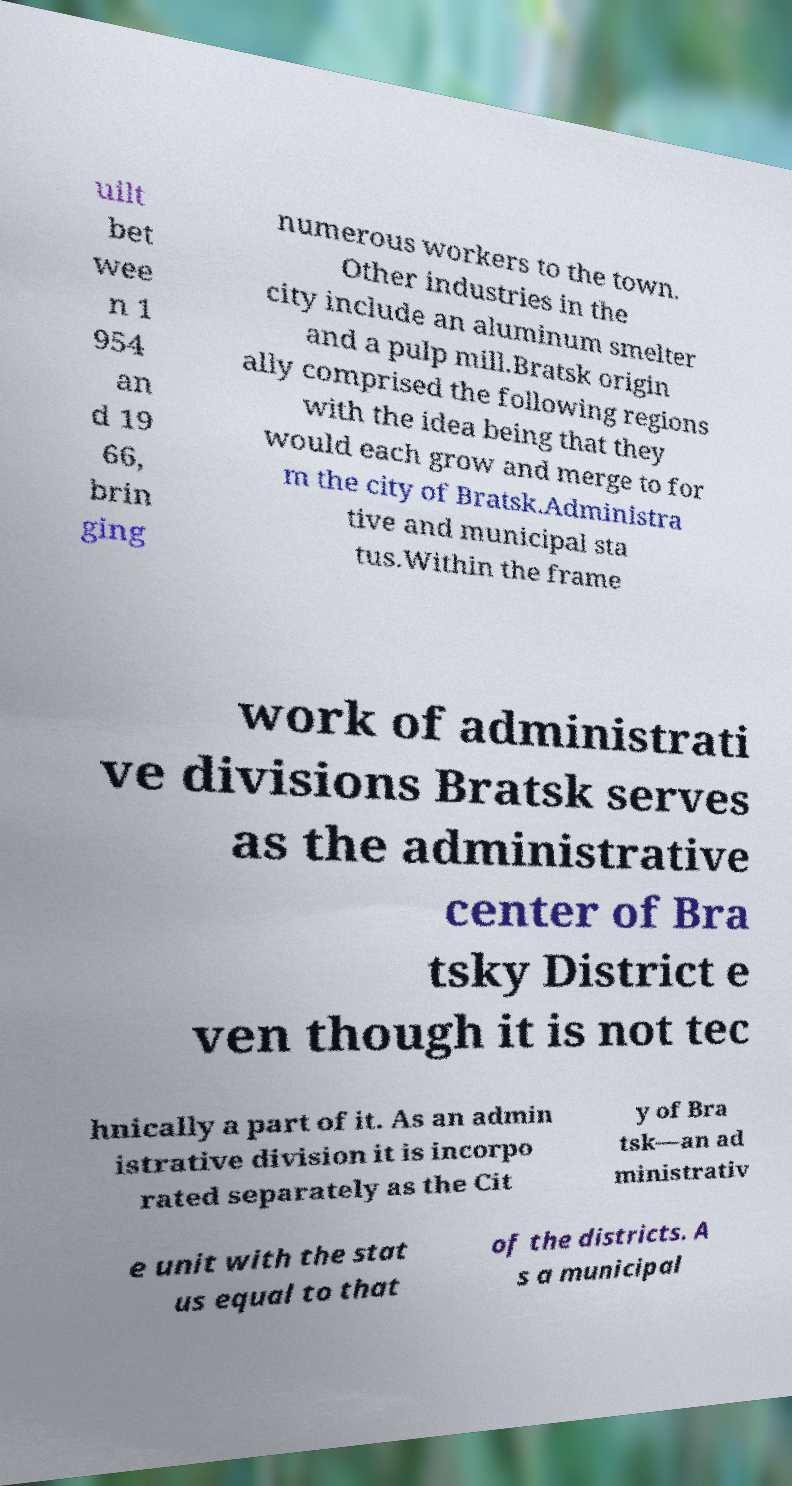Please identify and transcribe the text found in this image. uilt bet wee n 1 954 an d 19 66, brin ging numerous workers to the town. Other industries in the city include an aluminum smelter and a pulp mill.Bratsk origin ally comprised the following regions with the idea being that they would each grow and merge to for m the city of Bratsk.Administra tive and municipal sta tus.Within the frame work of administrati ve divisions Bratsk serves as the administrative center of Bra tsky District e ven though it is not tec hnically a part of it. As an admin istrative division it is incorpo rated separately as the Cit y of Bra tsk—an ad ministrativ e unit with the stat us equal to that of the districts. A s a municipal 